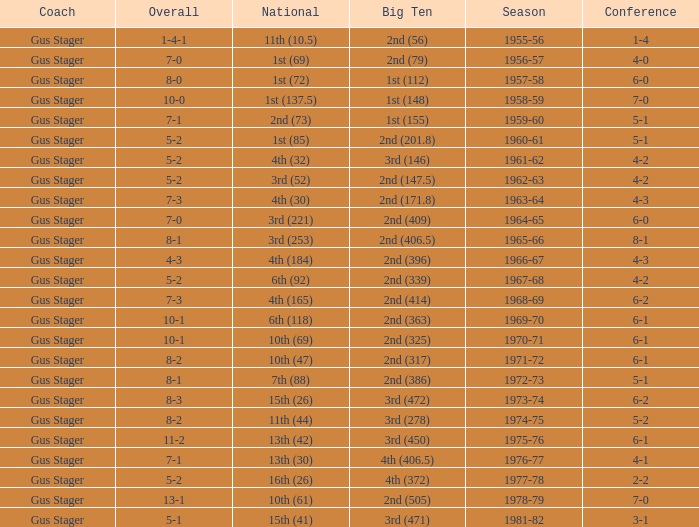What is the Coach with a Big Ten that is 1st (148)? Gus Stager. 